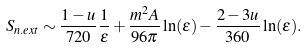<formula> <loc_0><loc_0><loc_500><loc_500>S _ { n . e x t } \sim \frac { 1 - u } { 7 2 0 } \frac { 1 } { \epsilon } + \frac { m ^ { 2 } A } { 9 6 \pi } \ln ( \epsilon ) - \frac { 2 - 3 u } { 3 6 0 } \ln ( \epsilon ) .</formula> 